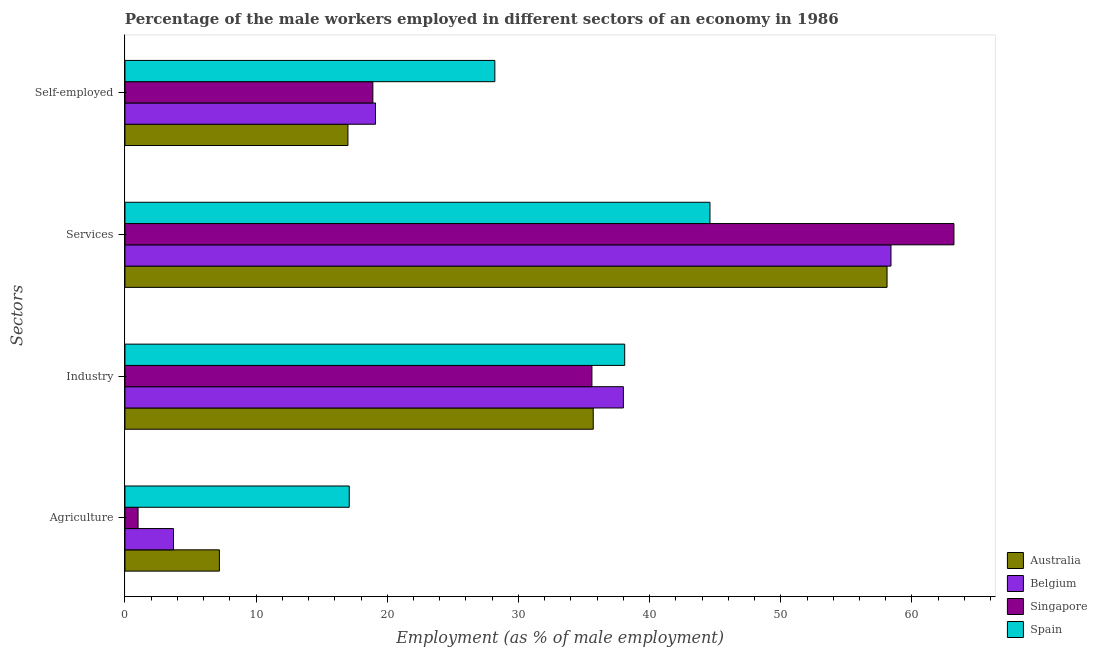How many different coloured bars are there?
Provide a short and direct response. 4. How many groups of bars are there?
Make the answer very short. 4. Are the number of bars on each tick of the Y-axis equal?
Ensure brevity in your answer.  Yes. How many bars are there on the 1st tick from the top?
Your answer should be very brief. 4. What is the label of the 1st group of bars from the top?
Your response must be concise. Self-employed. What is the percentage of male workers in services in Belgium?
Your response must be concise. 58.4. Across all countries, what is the maximum percentage of male workers in industry?
Provide a succinct answer. 38.1. In which country was the percentage of self employed male workers minimum?
Offer a terse response. Australia. What is the total percentage of male workers in industry in the graph?
Your response must be concise. 147.4. What is the difference between the percentage of male workers in agriculture in Belgium and that in Spain?
Your response must be concise. -13.4. What is the difference between the percentage of male workers in agriculture in Australia and the percentage of male workers in services in Spain?
Keep it short and to the point. -37.4. What is the average percentage of self employed male workers per country?
Keep it short and to the point. 20.8. What is the difference between the percentage of male workers in services and percentage of male workers in industry in Singapore?
Make the answer very short. 27.6. In how many countries, is the percentage of self employed male workers greater than 58 %?
Provide a short and direct response. 0. What is the ratio of the percentage of male workers in industry in Singapore to that in Spain?
Your answer should be very brief. 0.93. Is the difference between the percentage of male workers in services in Spain and Belgium greater than the difference between the percentage of self employed male workers in Spain and Belgium?
Give a very brief answer. No. What is the difference between the highest and the second highest percentage of male workers in services?
Offer a terse response. 4.8. What is the difference between the highest and the lowest percentage of self employed male workers?
Ensure brevity in your answer.  11.2. In how many countries, is the percentage of self employed male workers greater than the average percentage of self employed male workers taken over all countries?
Your response must be concise. 1. Is the sum of the percentage of self employed male workers in Australia and Spain greater than the maximum percentage of male workers in agriculture across all countries?
Make the answer very short. Yes. Is it the case that in every country, the sum of the percentage of male workers in industry and percentage of male workers in agriculture is greater than the sum of percentage of male workers in services and percentage of self employed male workers?
Your answer should be compact. No. What does the 3rd bar from the top in Self-employed represents?
Ensure brevity in your answer.  Belgium. What is the difference between two consecutive major ticks on the X-axis?
Ensure brevity in your answer.  10. Does the graph contain any zero values?
Make the answer very short. No. Does the graph contain grids?
Offer a terse response. No. How are the legend labels stacked?
Offer a terse response. Vertical. What is the title of the graph?
Your response must be concise. Percentage of the male workers employed in different sectors of an economy in 1986. Does "Thailand" appear as one of the legend labels in the graph?
Provide a short and direct response. No. What is the label or title of the X-axis?
Your answer should be compact. Employment (as % of male employment). What is the label or title of the Y-axis?
Give a very brief answer. Sectors. What is the Employment (as % of male employment) of Australia in Agriculture?
Ensure brevity in your answer.  7.2. What is the Employment (as % of male employment) in Belgium in Agriculture?
Your answer should be very brief. 3.7. What is the Employment (as % of male employment) in Spain in Agriculture?
Your answer should be very brief. 17.1. What is the Employment (as % of male employment) in Australia in Industry?
Provide a short and direct response. 35.7. What is the Employment (as % of male employment) of Belgium in Industry?
Provide a short and direct response. 38. What is the Employment (as % of male employment) of Singapore in Industry?
Provide a short and direct response. 35.6. What is the Employment (as % of male employment) of Spain in Industry?
Give a very brief answer. 38.1. What is the Employment (as % of male employment) in Australia in Services?
Provide a short and direct response. 58.1. What is the Employment (as % of male employment) of Belgium in Services?
Your answer should be compact. 58.4. What is the Employment (as % of male employment) of Singapore in Services?
Make the answer very short. 63.2. What is the Employment (as % of male employment) of Spain in Services?
Provide a succinct answer. 44.6. What is the Employment (as % of male employment) in Australia in Self-employed?
Offer a terse response. 17. What is the Employment (as % of male employment) in Belgium in Self-employed?
Keep it short and to the point. 19.1. What is the Employment (as % of male employment) of Singapore in Self-employed?
Provide a short and direct response. 18.9. What is the Employment (as % of male employment) in Spain in Self-employed?
Make the answer very short. 28.2. Across all Sectors, what is the maximum Employment (as % of male employment) in Australia?
Ensure brevity in your answer.  58.1. Across all Sectors, what is the maximum Employment (as % of male employment) of Belgium?
Provide a short and direct response. 58.4. Across all Sectors, what is the maximum Employment (as % of male employment) of Singapore?
Keep it short and to the point. 63.2. Across all Sectors, what is the maximum Employment (as % of male employment) in Spain?
Offer a very short reply. 44.6. Across all Sectors, what is the minimum Employment (as % of male employment) of Australia?
Offer a very short reply. 7.2. Across all Sectors, what is the minimum Employment (as % of male employment) in Belgium?
Provide a succinct answer. 3.7. Across all Sectors, what is the minimum Employment (as % of male employment) of Spain?
Provide a succinct answer. 17.1. What is the total Employment (as % of male employment) in Australia in the graph?
Offer a very short reply. 118. What is the total Employment (as % of male employment) of Belgium in the graph?
Offer a terse response. 119.2. What is the total Employment (as % of male employment) in Singapore in the graph?
Give a very brief answer. 118.7. What is the total Employment (as % of male employment) in Spain in the graph?
Make the answer very short. 128. What is the difference between the Employment (as % of male employment) of Australia in Agriculture and that in Industry?
Your answer should be compact. -28.5. What is the difference between the Employment (as % of male employment) in Belgium in Agriculture and that in Industry?
Offer a terse response. -34.3. What is the difference between the Employment (as % of male employment) of Singapore in Agriculture and that in Industry?
Provide a succinct answer. -34.6. What is the difference between the Employment (as % of male employment) of Australia in Agriculture and that in Services?
Provide a succinct answer. -50.9. What is the difference between the Employment (as % of male employment) of Belgium in Agriculture and that in Services?
Your answer should be compact. -54.7. What is the difference between the Employment (as % of male employment) of Singapore in Agriculture and that in Services?
Provide a succinct answer. -62.2. What is the difference between the Employment (as % of male employment) in Spain in Agriculture and that in Services?
Give a very brief answer. -27.5. What is the difference between the Employment (as % of male employment) in Australia in Agriculture and that in Self-employed?
Your answer should be compact. -9.8. What is the difference between the Employment (as % of male employment) of Belgium in Agriculture and that in Self-employed?
Offer a very short reply. -15.4. What is the difference between the Employment (as % of male employment) in Singapore in Agriculture and that in Self-employed?
Offer a terse response. -17.9. What is the difference between the Employment (as % of male employment) in Australia in Industry and that in Services?
Ensure brevity in your answer.  -22.4. What is the difference between the Employment (as % of male employment) of Belgium in Industry and that in Services?
Your response must be concise. -20.4. What is the difference between the Employment (as % of male employment) in Singapore in Industry and that in Services?
Provide a short and direct response. -27.6. What is the difference between the Employment (as % of male employment) of Australia in Industry and that in Self-employed?
Make the answer very short. 18.7. What is the difference between the Employment (as % of male employment) in Belgium in Industry and that in Self-employed?
Provide a short and direct response. 18.9. What is the difference between the Employment (as % of male employment) in Singapore in Industry and that in Self-employed?
Provide a short and direct response. 16.7. What is the difference between the Employment (as % of male employment) of Spain in Industry and that in Self-employed?
Provide a short and direct response. 9.9. What is the difference between the Employment (as % of male employment) of Australia in Services and that in Self-employed?
Provide a short and direct response. 41.1. What is the difference between the Employment (as % of male employment) of Belgium in Services and that in Self-employed?
Make the answer very short. 39.3. What is the difference between the Employment (as % of male employment) in Singapore in Services and that in Self-employed?
Your response must be concise. 44.3. What is the difference between the Employment (as % of male employment) in Spain in Services and that in Self-employed?
Make the answer very short. 16.4. What is the difference between the Employment (as % of male employment) in Australia in Agriculture and the Employment (as % of male employment) in Belgium in Industry?
Provide a short and direct response. -30.8. What is the difference between the Employment (as % of male employment) in Australia in Agriculture and the Employment (as % of male employment) in Singapore in Industry?
Provide a succinct answer. -28.4. What is the difference between the Employment (as % of male employment) of Australia in Agriculture and the Employment (as % of male employment) of Spain in Industry?
Provide a succinct answer. -30.9. What is the difference between the Employment (as % of male employment) of Belgium in Agriculture and the Employment (as % of male employment) of Singapore in Industry?
Provide a short and direct response. -31.9. What is the difference between the Employment (as % of male employment) of Belgium in Agriculture and the Employment (as % of male employment) of Spain in Industry?
Ensure brevity in your answer.  -34.4. What is the difference between the Employment (as % of male employment) in Singapore in Agriculture and the Employment (as % of male employment) in Spain in Industry?
Provide a succinct answer. -37.1. What is the difference between the Employment (as % of male employment) of Australia in Agriculture and the Employment (as % of male employment) of Belgium in Services?
Keep it short and to the point. -51.2. What is the difference between the Employment (as % of male employment) in Australia in Agriculture and the Employment (as % of male employment) in Singapore in Services?
Provide a succinct answer. -56. What is the difference between the Employment (as % of male employment) of Australia in Agriculture and the Employment (as % of male employment) of Spain in Services?
Keep it short and to the point. -37.4. What is the difference between the Employment (as % of male employment) in Belgium in Agriculture and the Employment (as % of male employment) in Singapore in Services?
Provide a short and direct response. -59.5. What is the difference between the Employment (as % of male employment) of Belgium in Agriculture and the Employment (as % of male employment) of Spain in Services?
Your answer should be very brief. -40.9. What is the difference between the Employment (as % of male employment) of Singapore in Agriculture and the Employment (as % of male employment) of Spain in Services?
Your response must be concise. -43.6. What is the difference between the Employment (as % of male employment) of Australia in Agriculture and the Employment (as % of male employment) of Belgium in Self-employed?
Your answer should be very brief. -11.9. What is the difference between the Employment (as % of male employment) of Australia in Agriculture and the Employment (as % of male employment) of Singapore in Self-employed?
Provide a succinct answer. -11.7. What is the difference between the Employment (as % of male employment) of Belgium in Agriculture and the Employment (as % of male employment) of Singapore in Self-employed?
Provide a short and direct response. -15.2. What is the difference between the Employment (as % of male employment) of Belgium in Agriculture and the Employment (as % of male employment) of Spain in Self-employed?
Offer a terse response. -24.5. What is the difference between the Employment (as % of male employment) in Singapore in Agriculture and the Employment (as % of male employment) in Spain in Self-employed?
Keep it short and to the point. -27.2. What is the difference between the Employment (as % of male employment) in Australia in Industry and the Employment (as % of male employment) in Belgium in Services?
Offer a terse response. -22.7. What is the difference between the Employment (as % of male employment) in Australia in Industry and the Employment (as % of male employment) in Singapore in Services?
Make the answer very short. -27.5. What is the difference between the Employment (as % of male employment) in Australia in Industry and the Employment (as % of male employment) in Spain in Services?
Your answer should be compact. -8.9. What is the difference between the Employment (as % of male employment) of Belgium in Industry and the Employment (as % of male employment) of Singapore in Services?
Provide a short and direct response. -25.2. What is the difference between the Employment (as % of male employment) of Belgium in Industry and the Employment (as % of male employment) of Spain in Services?
Give a very brief answer. -6.6. What is the difference between the Employment (as % of male employment) in Singapore in Industry and the Employment (as % of male employment) in Spain in Services?
Give a very brief answer. -9. What is the difference between the Employment (as % of male employment) in Australia in Industry and the Employment (as % of male employment) in Belgium in Self-employed?
Your response must be concise. 16.6. What is the difference between the Employment (as % of male employment) in Australia in Services and the Employment (as % of male employment) in Singapore in Self-employed?
Offer a terse response. 39.2. What is the difference between the Employment (as % of male employment) of Australia in Services and the Employment (as % of male employment) of Spain in Self-employed?
Offer a very short reply. 29.9. What is the difference between the Employment (as % of male employment) in Belgium in Services and the Employment (as % of male employment) in Singapore in Self-employed?
Make the answer very short. 39.5. What is the difference between the Employment (as % of male employment) of Belgium in Services and the Employment (as % of male employment) of Spain in Self-employed?
Keep it short and to the point. 30.2. What is the difference between the Employment (as % of male employment) of Singapore in Services and the Employment (as % of male employment) of Spain in Self-employed?
Make the answer very short. 35. What is the average Employment (as % of male employment) in Australia per Sectors?
Give a very brief answer. 29.5. What is the average Employment (as % of male employment) in Belgium per Sectors?
Ensure brevity in your answer.  29.8. What is the average Employment (as % of male employment) of Singapore per Sectors?
Keep it short and to the point. 29.68. What is the difference between the Employment (as % of male employment) of Belgium and Employment (as % of male employment) of Singapore in Agriculture?
Provide a succinct answer. 2.7. What is the difference between the Employment (as % of male employment) in Belgium and Employment (as % of male employment) in Spain in Agriculture?
Offer a terse response. -13.4. What is the difference between the Employment (as % of male employment) in Singapore and Employment (as % of male employment) in Spain in Agriculture?
Provide a succinct answer. -16.1. What is the difference between the Employment (as % of male employment) of Australia and Employment (as % of male employment) of Singapore in Industry?
Provide a short and direct response. 0.1. What is the difference between the Employment (as % of male employment) of Australia and Employment (as % of male employment) of Spain in Industry?
Your answer should be very brief. -2.4. What is the difference between the Employment (as % of male employment) of Singapore and Employment (as % of male employment) of Spain in Industry?
Your answer should be compact. -2.5. What is the difference between the Employment (as % of male employment) of Australia and Employment (as % of male employment) of Belgium in Services?
Offer a very short reply. -0.3. What is the difference between the Employment (as % of male employment) of Belgium and Employment (as % of male employment) of Singapore in Services?
Keep it short and to the point. -4.8. What is the difference between the Employment (as % of male employment) of Belgium and Employment (as % of male employment) of Spain in Services?
Keep it short and to the point. 13.8. What is the difference between the Employment (as % of male employment) of Australia and Employment (as % of male employment) of Singapore in Self-employed?
Give a very brief answer. -1.9. What is the difference between the Employment (as % of male employment) of Australia and Employment (as % of male employment) of Spain in Self-employed?
Offer a very short reply. -11.2. What is the difference between the Employment (as % of male employment) of Belgium and Employment (as % of male employment) of Singapore in Self-employed?
Give a very brief answer. 0.2. What is the difference between the Employment (as % of male employment) of Belgium and Employment (as % of male employment) of Spain in Self-employed?
Give a very brief answer. -9.1. What is the ratio of the Employment (as % of male employment) of Australia in Agriculture to that in Industry?
Give a very brief answer. 0.2. What is the ratio of the Employment (as % of male employment) in Belgium in Agriculture to that in Industry?
Ensure brevity in your answer.  0.1. What is the ratio of the Employment (as % of male employment) of Singapore in Agriculture to that in Industry?
Your answer should be very brief. 0.03. What is the ratio of the Employment (as % of male employment) in Spain in Agriculture to that in Industry?
Your answer should be very brief. 0.45. What is the ratio of the Employment (as % of male employment) of Australia in Agriculture to that in Services?
Provide a short and direct response. 0.12. What is the ratio of the Employment (as % of male employment) in Belgium in Agriculture to that in Services?
Keep it short and to the point. 0.06. What is the ratio of the Employment (as % of male employment) in Singapore in Agriculture to that in Services?
Give a very brief answer. 0.02. What is the ratio of the Employment (as % of male employment) in Spain in Agriculture to that in Services?
Your answer should be very brief. 0.38. What is the ratio of the Employment (as % of male employment) in Australia in Agriculture to that in Self-employed?
Offer a terse response. 0.42. What is the ratio of the Employment (as % of male employment) of Belgium in Agriculture to that in Self-employed?
Keep it short and to the point. 0.19. What is the ratio of the Employment (as % of male employment) of Singapore in Agriculture to that in Self-employed?
Provide a short and direct response. 0.05. What is the ratio of the Employment (as % of male employment) of Spain in Agriculture to that in Self-employed?
Your answer should be very brief. 0.61. What is the ratio of the Employment (as % of male employment) in Australia in Industry to that in Services?
Your response must be concise. 0.61. What is the ratio of the Employment (as % of male employment) in Belgium in Industry to that in Services?
Give a very brief answer. 0.65. What is the ratio of the Employment (as % of male employment) in Singapore in Industry to that in Services?
Ensure brevity in your answer.  0.56. What is the ratio of the Employment (as % of male employment) in Spain in Industry to that in Services?
Give a very brief answer. 0.85. What is the ratio of the Employment (as % of male employment) of Belgium in Industry to that in Self-employed?
Provide a short and direct response. 1.99. What is the ratio of the Employment (as % of male employment) in Singapore in Industry to that in Self-employed?
Your answer should be compact. 1.88. What is the ratio of the Employment (as % of male employment) of Spain in Industry to that in Self-employed?
Your answer should be very brief. 1.35. What is the ratio of the Employment (as % of male employment) of Australia in Services to that in Self-employed?
Keep it short and to the point. 3.42. What is the ratio of the Employment (as % of male employment) of Belgium in Services to that in Self-employed?
Make the answer very short. 3.06. What is the ratio of the Employment (as % of male employment) of Singapore in Services to that in Self-employed?
Give a very brief answer. 3.34. What is the ratio of the Employment (as % of male employment) of Spain in Services to that in Self-employed?
Your answer should be compact. 1.58. What is the difference between the highest and the second highest Employment (as % of male employment) in Australia?
Your response must be concise. 22.4. What is the difference between the highest and the second highest Employment (as % of male employment) of Belgium?
Your answer should be very brief. 20.4. What is the difference between the highest and the second highest Employment (as % of male employment) in Singapore?
Ensure brevity in your answer.  27.6. What is the difference between the highest and the second highest Employment (as % of male employment) of Spain?
Your answer should be very brief. 6.5. What is the difference between the highest and the lowest Employment (as % of male employment) in Australia?
Give a very brief answer. 50.9. What is the difference between the highest and the lowest Employment (as % of male employment) of Belgium?
Provide a succinct answer. 54.7. What is the difference between the highest and the lowest Employment (as % of male employment) of Singapore?
Provide a succinct answer. 62.2. What is the difference between the highest and the lowest Employment (as % of male employment) of Spain?
Keep it short and to the point. 27.5. 